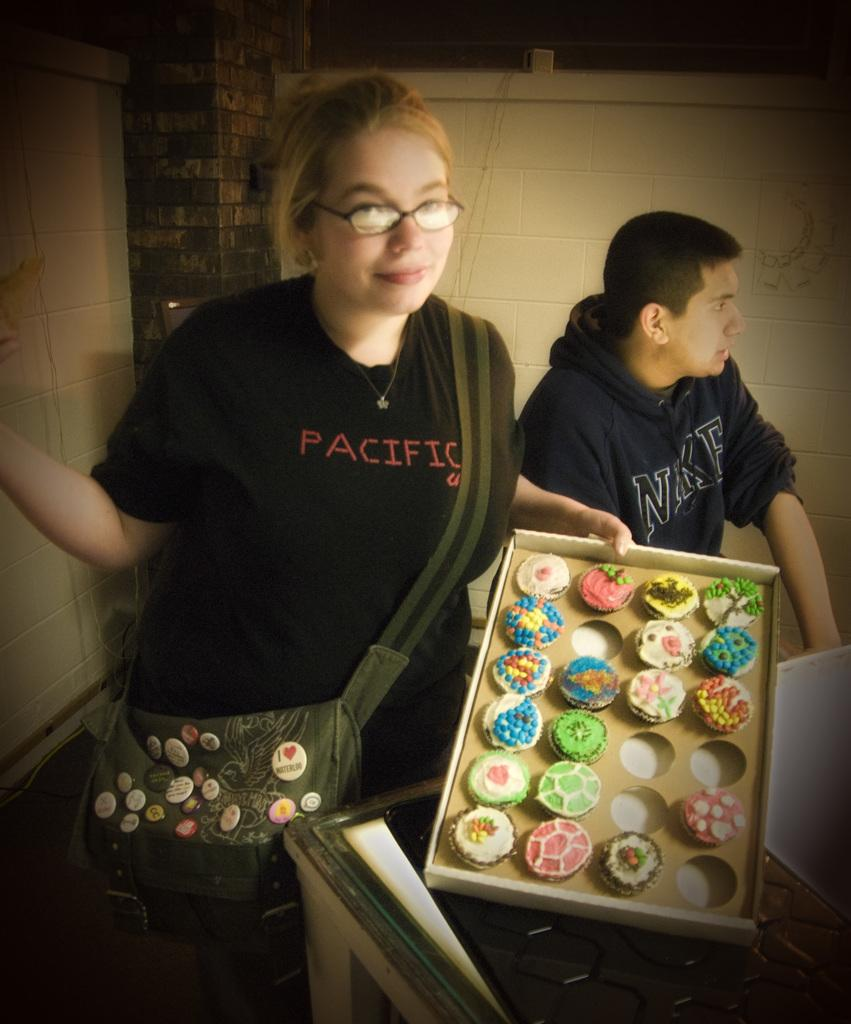How many people are present in the image? There are people in the image, but the exact number cannot be determined from the provided facts. What is the person holding in the image? A person is holding an object in the image, but the specific object cannot be identified from the provided facts. What type of food can be seen in the image? There are cakes in the image, which are a type of food. What is the background of the image? There is a wall in the image, which suggests a possible background or setting. What else is visible in the image? There is a bag in the image, but its contents or purpose cannot be determined from the provided facts. How many rabbits are visible in the image? There are no rabbits present in the image. What type of bread is being served in the image? There is no bread present in the image. 